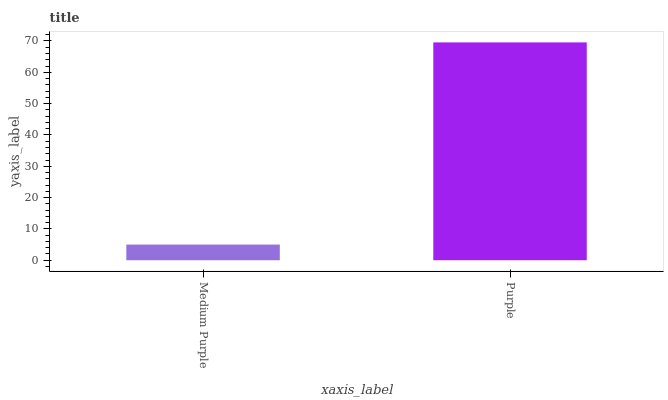Is Purple the minimum?
Answer yes or no. No. Is Purple greater than Medium Purple?
Answer yes or no. Yes. Is Medium Purple less than Purple?
Answer yes or no. Yes. Is Medium Purple greater than Purple?
Answer yes or no. No. Is Purple less than Medium Purple?
Answer yes or no. No. Is Purple the high median?
Answer yes or no. Yes. Is Medium Purple the low median?
Answer yes or no. Yes. Is Medium Purple the high median?
Answer yes or no. No. Is Purple the low median?
Answer yes or no. No. 